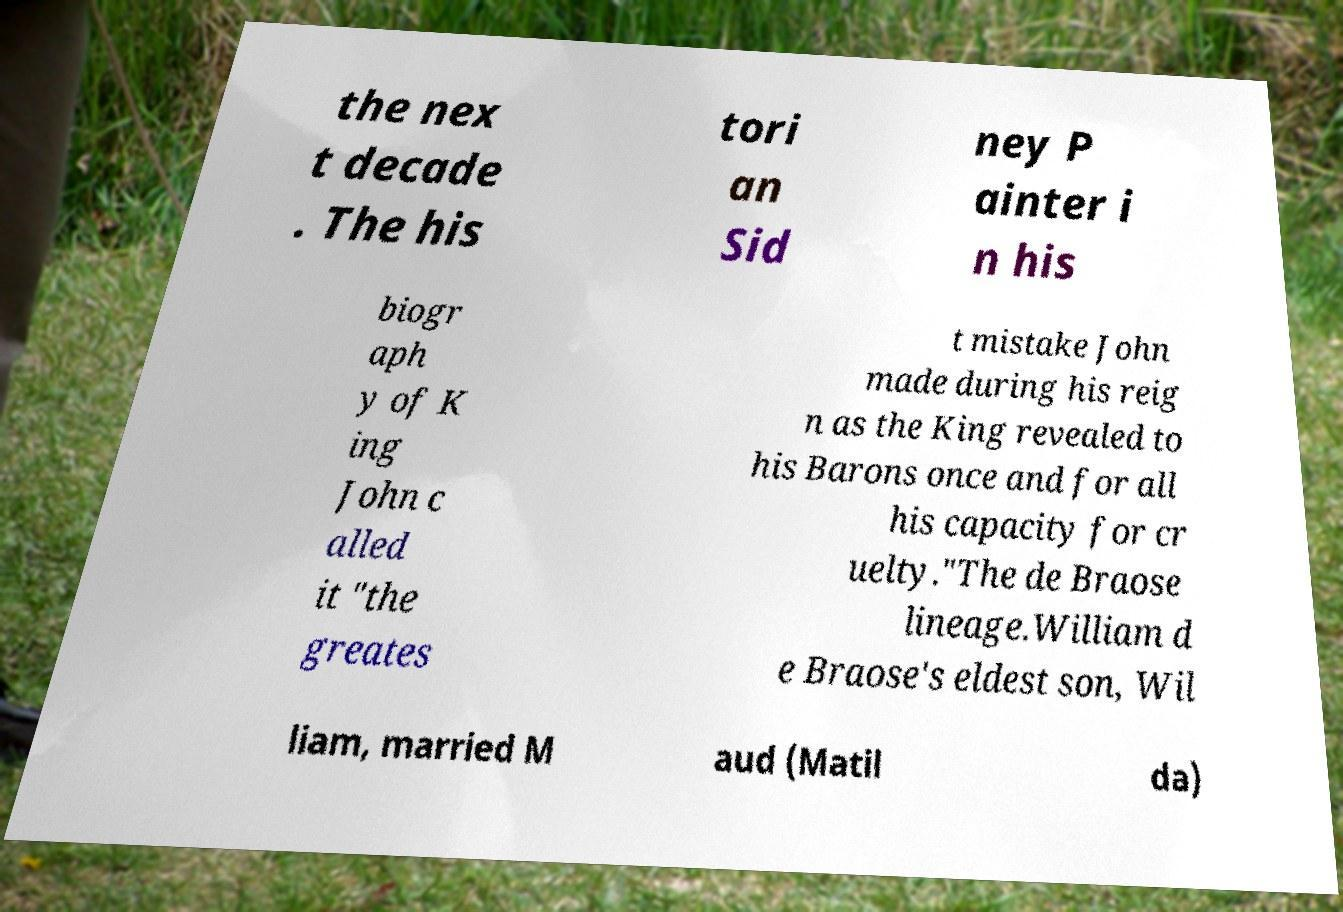Could you extract and type out the text from this image? the nex t decade . The his tori an Sid ney P ainter i n his biogr aph y of K ing John c alled it "the greates t mistake John made during his reig n as the King revealed to his Barons once and for all his capacity for cr uelty."The de Braose lineage.William d e Braose's eldest son, Wil liam, married M aud (Matil da) 